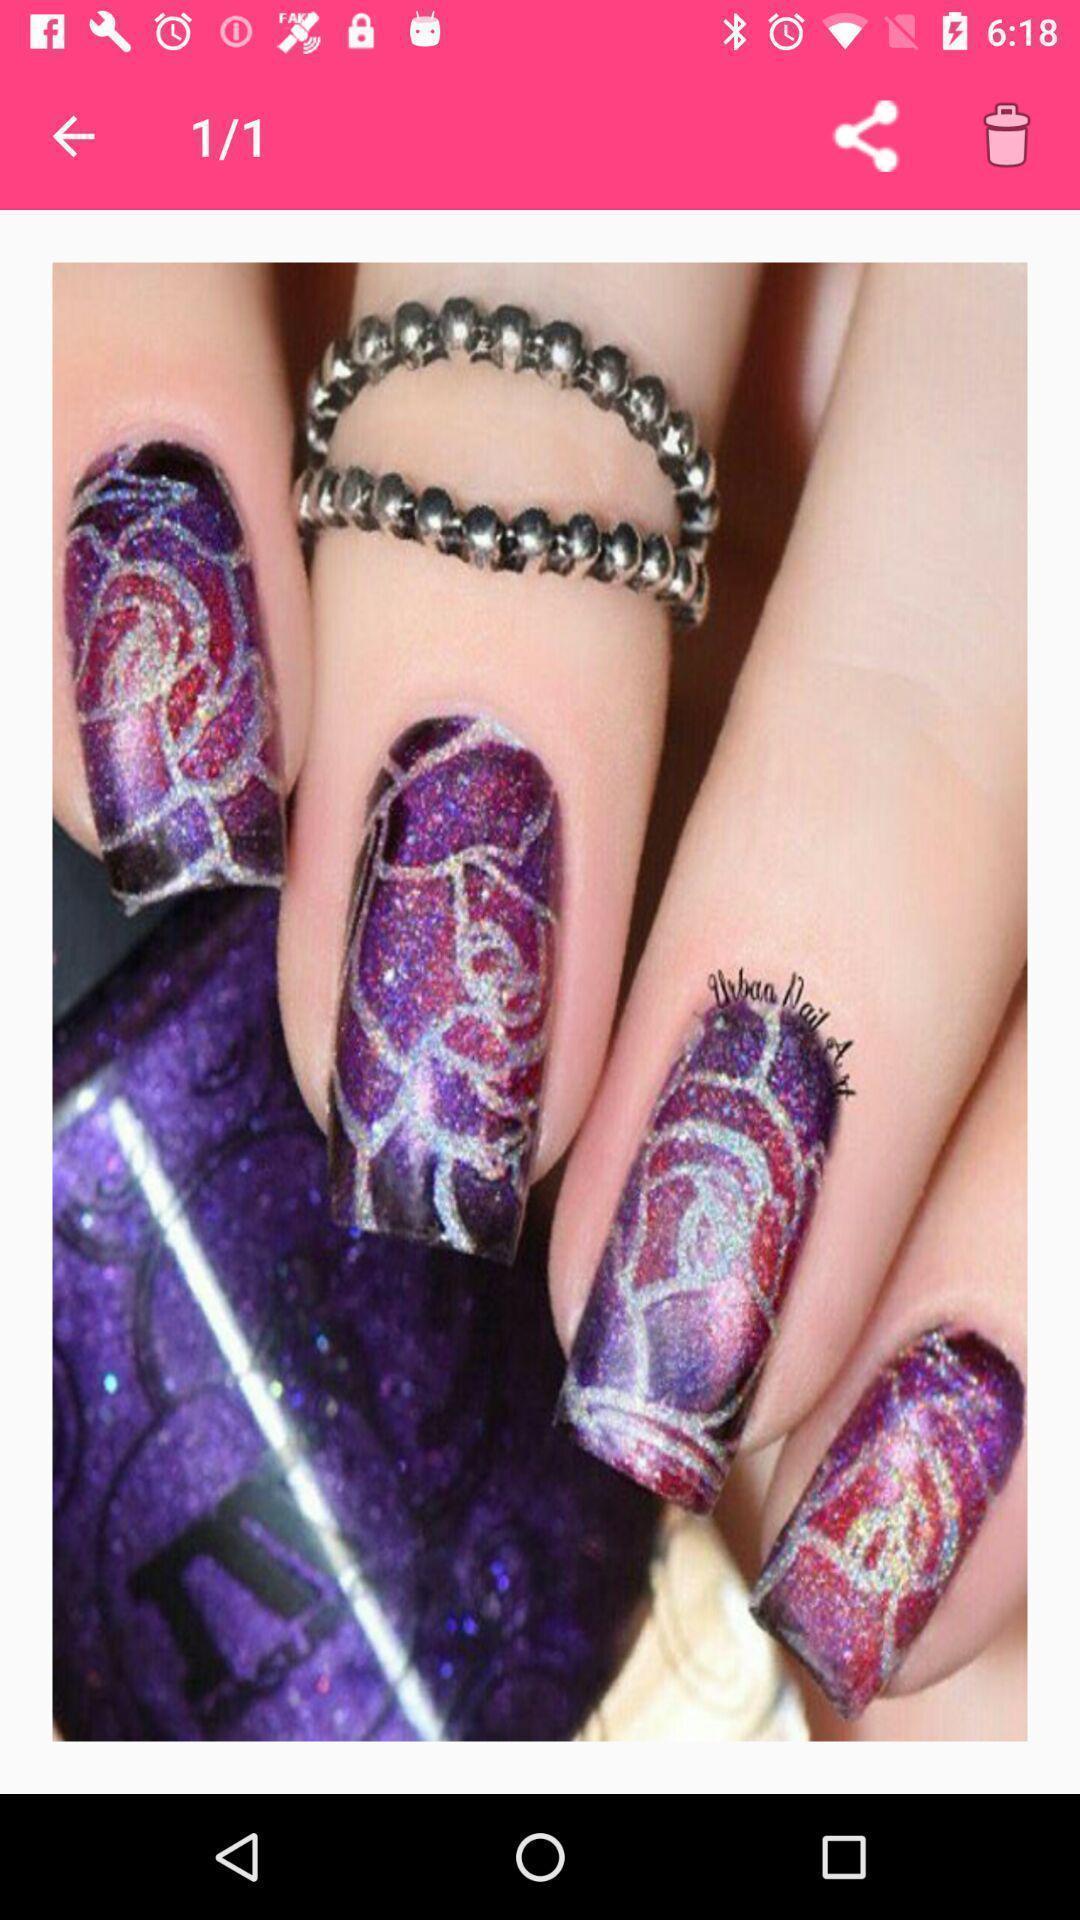Provide a description of this screenshot. Page displaying with image and few options. 